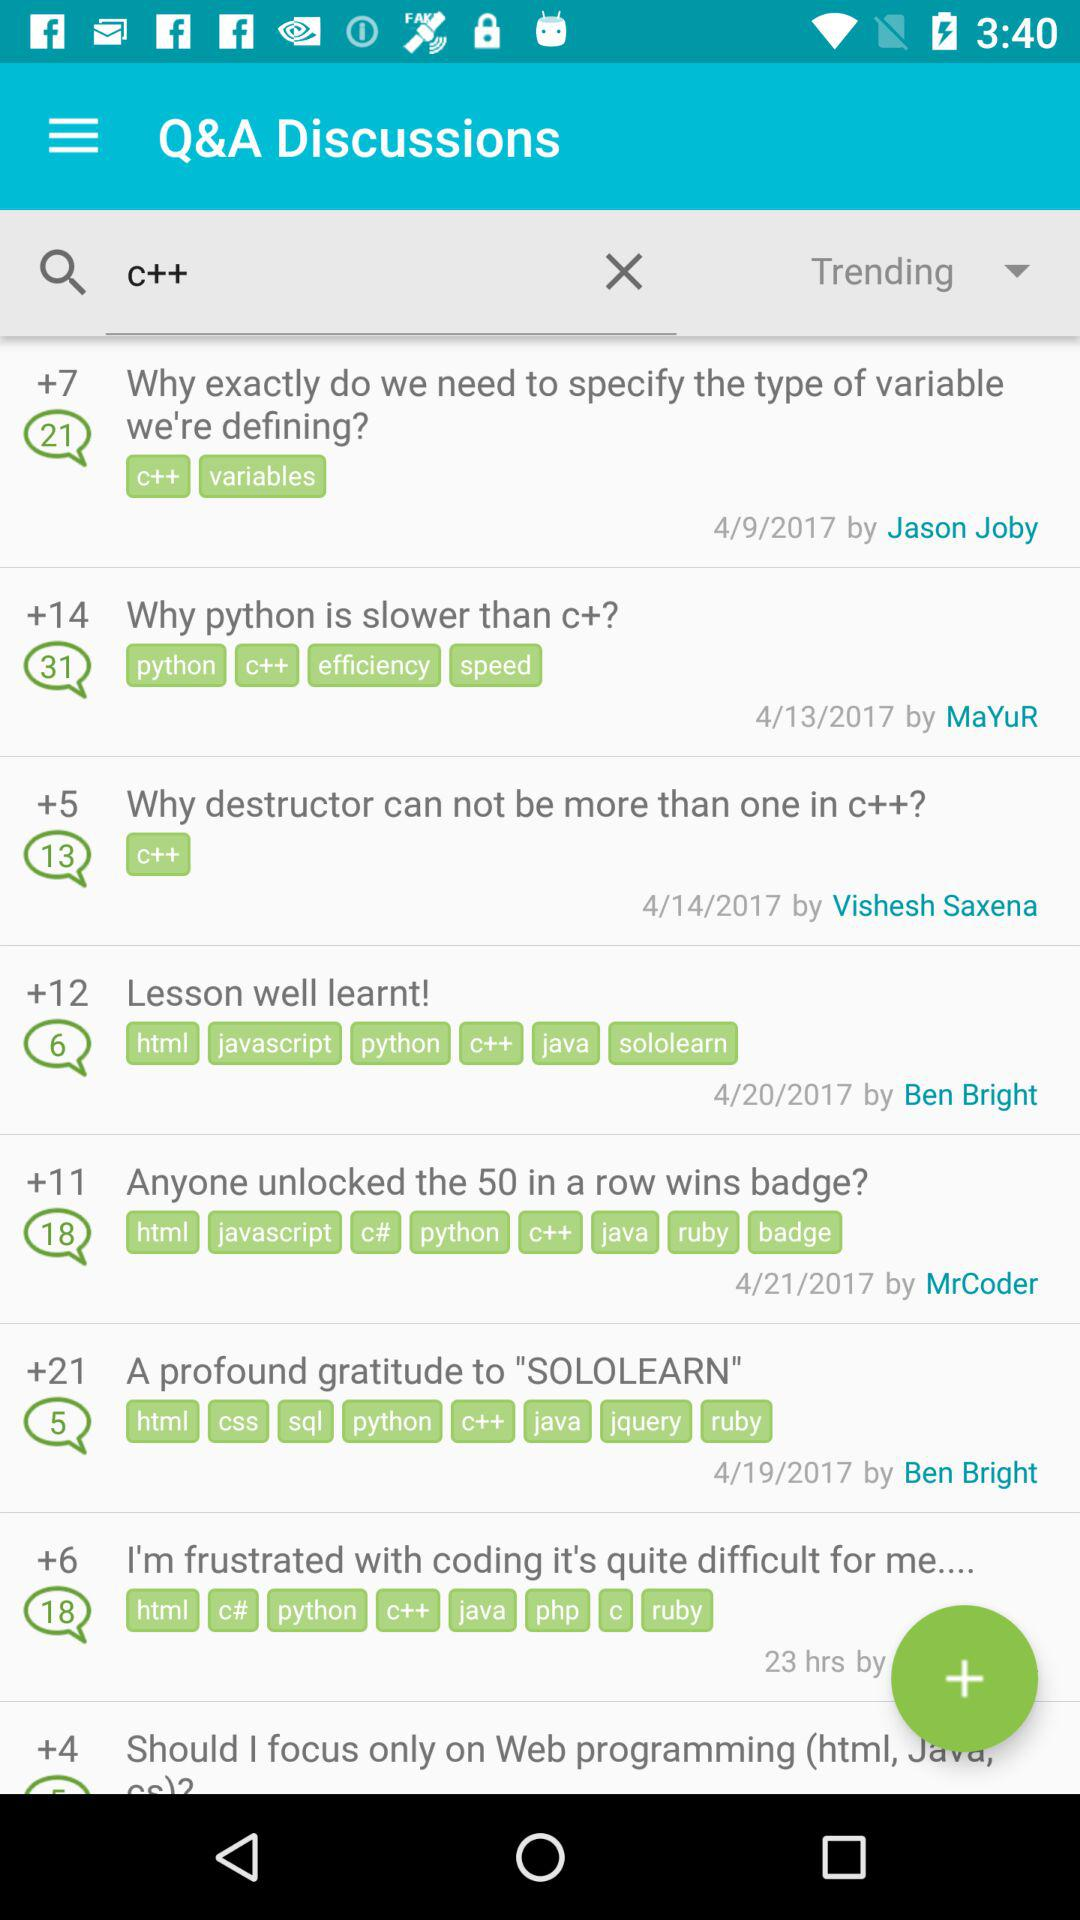How many comments are shown on the post "Why Python is Slower Than C+"? There are 31 comments. 